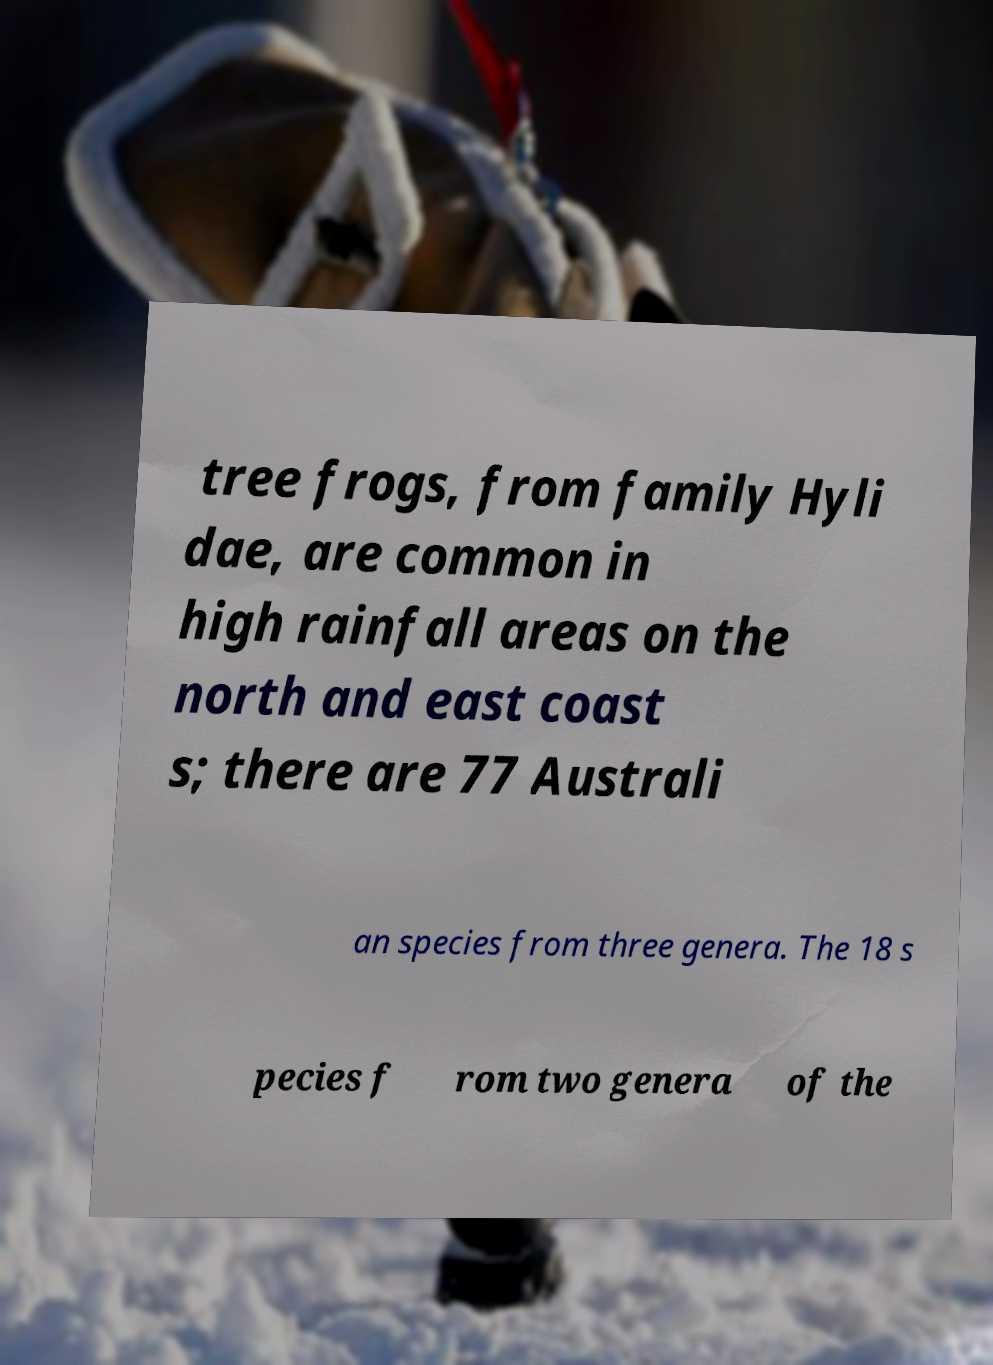For documentation purposes, I need the text within this image transcribed. Could you provide that? tree frogs, from family Hyli dae, are common in high rainfall areas on the north and east coast s; there are 77 Australi an species from three genera. The 18 s pecies f rom two genera of the 